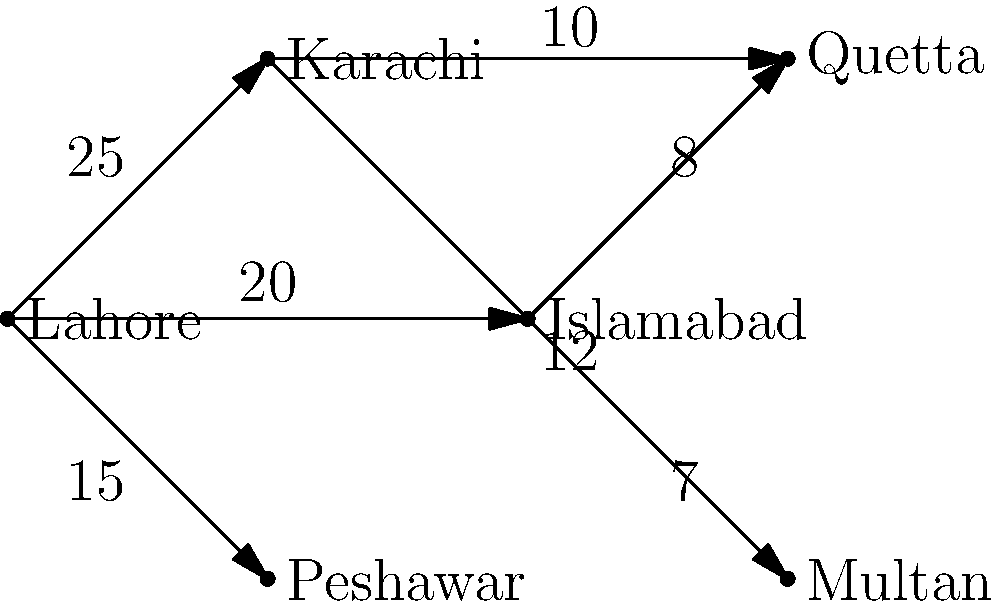In the weighted graph representing the distribution of votes across different regions of Pakistan, what is the total number of votes that can be influenced by Lahore's political stance, considering both direct and indirect connections? To solve this problem, we need to follow these steps:

1. Identify Lahore's direct connections:
   - Lahore to Karachi: 25 votes
   - Lahore to Islamabad: 20 votes
   - Lahore to Peshawar: 15 votes

2. Sum up the direct connections:
   $25 + 20 + 15 = 60$ votes

3. Identify indirect connections through Karachi:
   - Karachi to Quetta: 10 votes
   - Karachi to Multan: 12 votes

4. Identify indirect connections through Islamabad:
   - Islamabad to Quetta: 8 votes
   - Islamabad to Multan: 7 votes

5. Sum up the indirect connections:
   $10 + 12 + 8 + 7 = 37$ votes

6. Calculate the total number of votes influenced:
   Direct votes + Indirect votes = $60 + 37 = 97$ votes

Therefore, Lahore's political stance can influence a total of 97 votes considering both direct and indirect connections.
Answer: 97 votes 